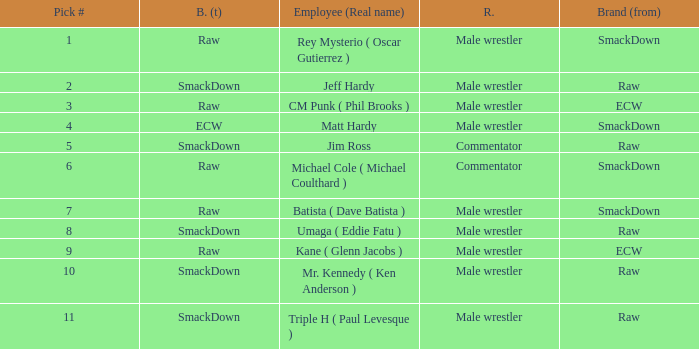Pick # 3 works for which brand? ECW. 